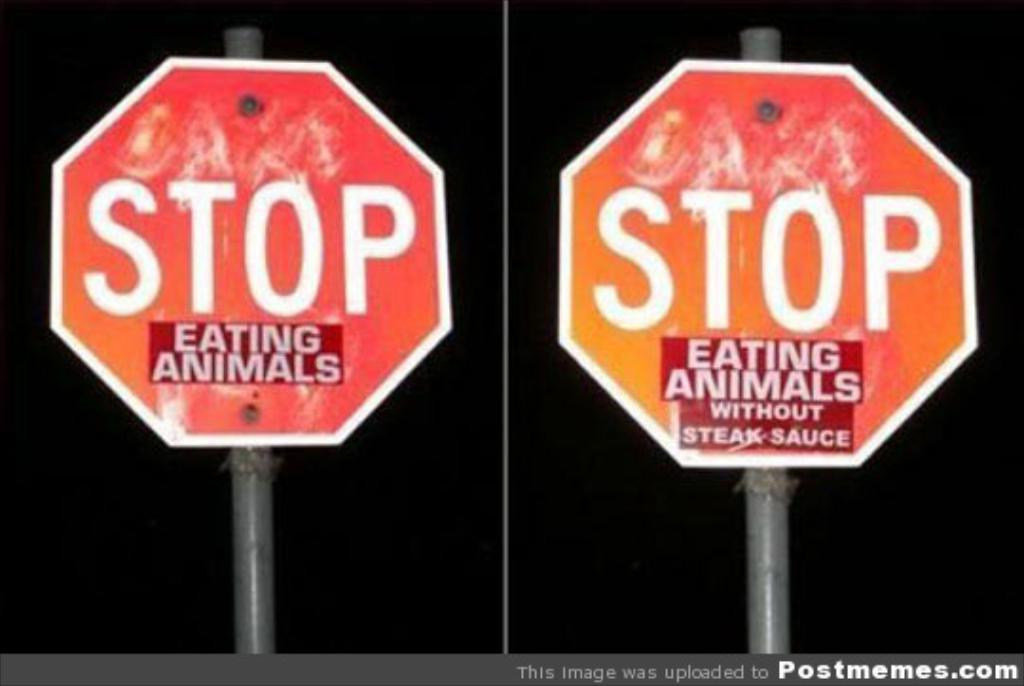<image>
Share a concise interpretation of the image provided. The first picture shows a Stop sign with the words Stop Eating Animals and the second stop sign says Stop Eating Animals without Steak Sauce. 